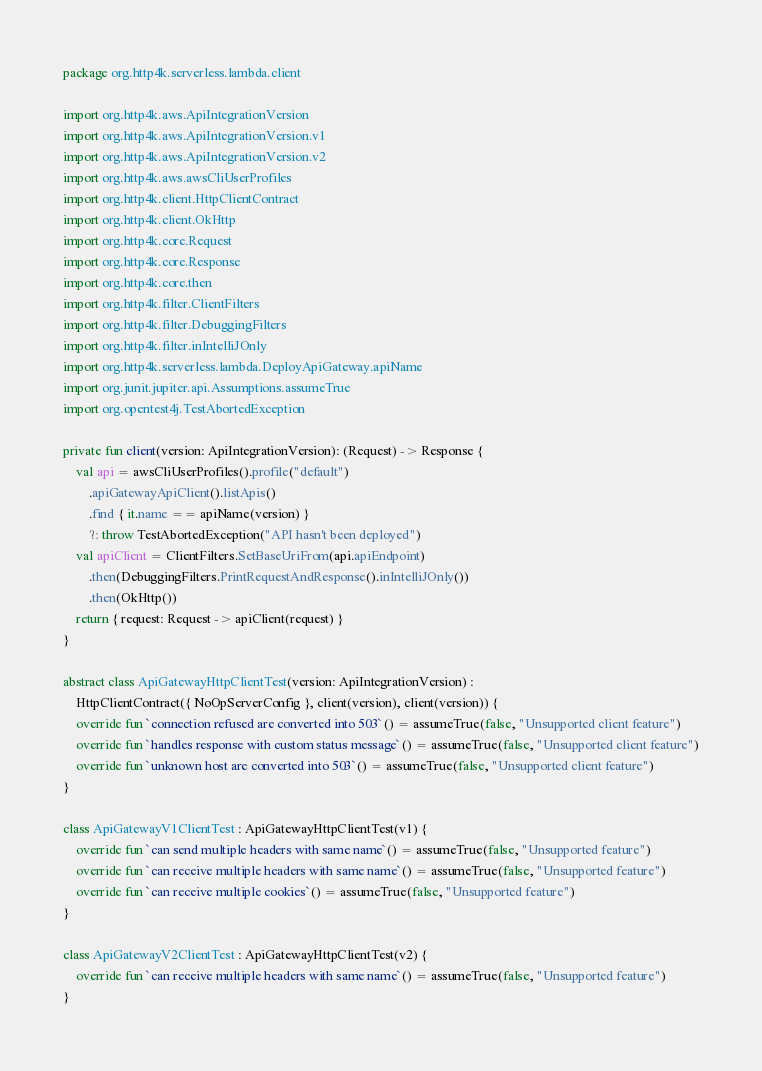Convert code to text. <code><loc_0><loc_0><loc_500><loc_500><_Kotlin_>package org.http4k.serverless.lambda.client

import org.http4k.aws.ApiIntegrationVersion
import org.http4k.aws.ApiIntegrationVersion.v1
import org.http4k.aws.ApiIntegrationVersion.v2
import org.http4k.aws.awsCliUserProfiles
import org.http4k.client.HttpClientContract
import org.http4k.client.OkHttp
import org.http4k.core.Request
import org.http4k.core.Response
import org.http4k.core.then
import org.http4k.filter.ClientFilters
import org.http4k.filter.DebuggingFilters
import org.http4k.filter.inIntelliJOnly
import org.http4k.serverless.lambda.DeployApiGateway.apiName
import org.junit.jupiter.api.Assumptions.assumeTrue
import org.opentest4j.TestAbortedException

private fun client(version: ApiIntegrationVersion): (Request) -> Response {
    val api = awsCliUserProfiles().profile("default")
        .apiGatewayApiClient().listApis()
        .find { it.name == apiName(version) }
        ?: throw TestAbortedException("API hasn't been deployed")
    val apiClient = ClientFilters.SetBaseUriFrom(api.apiEndpoint)
        .then(DebuggingFilters.PrintRequestAndResponse().inIntelliJOnly())
        .then(OkHttp())
    return { request: Request -> apiClient(request) }
}

abstract class ApiGatewayHttpClientTest(version: ApiIntegrationVersion) :
    HttpClientContract({ NoOpServerConfig }, client(version), client(version)) {
    override fun `connection refused are converted into 503`() = assumeTrue(false, "Unsupported client feature")
    override fun `handles response with custom status message`() = assumeTrue(false, "Unsupported client feature")
    override fun `unknown host are converted into 503`() = assumeTrue(false, "Unsupported client feature")
}

class ApiGatewayV1ClientTest : ApiGatewayHttpClientTest(v1) {
    override fun `can send multiple headers with same name`() = assumeTrue(false, "Unsupported feature")
    override fun `can receive multiple headers with same name`() = assumeTrue(false, "Unsupported feature")
    override fun `can receive multiple cookies`() = assumeTrue(false, "Unsupported feature")
}

class ApiGatewayV2ClientTest : ApiGatewayHttpClientTest(v2) {
    override fun `can receive multiple headers with same name`() = assumeTrue(false, "Unsupported feature")
}
</code> 